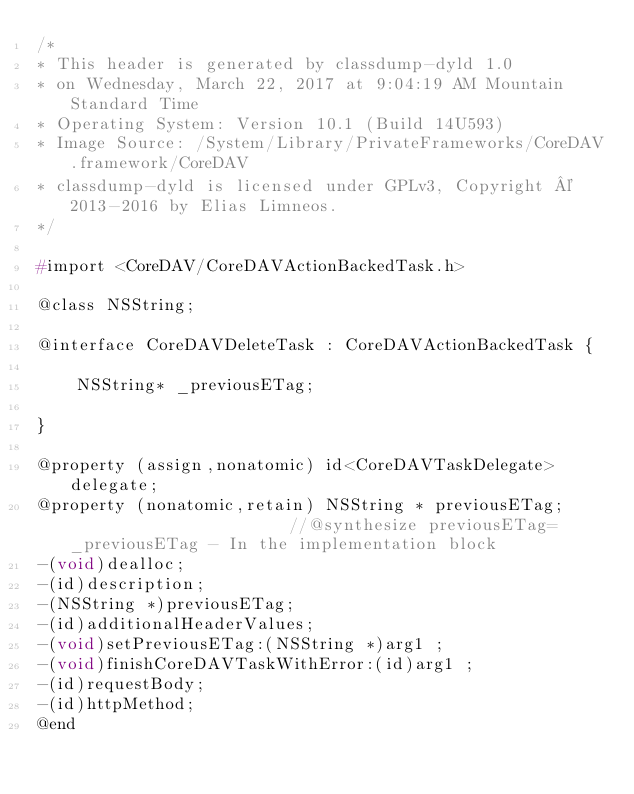<code> <loc_0><loc_0><loc_500><loc_500><_C_>/*
* This header is generated by classdump-dyld 1.0
* on Wednesday, March 22, 2017 at 9:04:19 AM Mountain Standard Time
* Operating System: Version 10.1 (Build 14U593)
* Image Source: /System/Library/PrivateFrameworks/CoreDAV.framework/CoreDAV
* classdump-dyld is licensed under GPLv3, Copyright © 2013-2016 by Elias Limneos.
*/

#import <CoreDAV/CoreDAVActionBackedTask.h>

@class NSString;

@interface CoreDAVDeleteTask : CoreDAVActionBackedTask {

	NSString* _previousETag;

}

@property (assign,nonatomic) id<CoreDAVTaskDelegate> delegate; 
@property (nonatomic,retain) NSString * previousETag;                       //@synthesize previousETag=_previousETag - In the implementation block
-(void)dealloc;
-(id)description;
-(NSString *)previousETag;
-(id)additionalHeaderValues;
-(void)setPreviousETag:(NSString *)arg1 ;
-(void)finishCoreDAVTaskWithError:(id)arg1 ;
-(id)requestBody;
-(id)httpMethod;
@end

</code> 